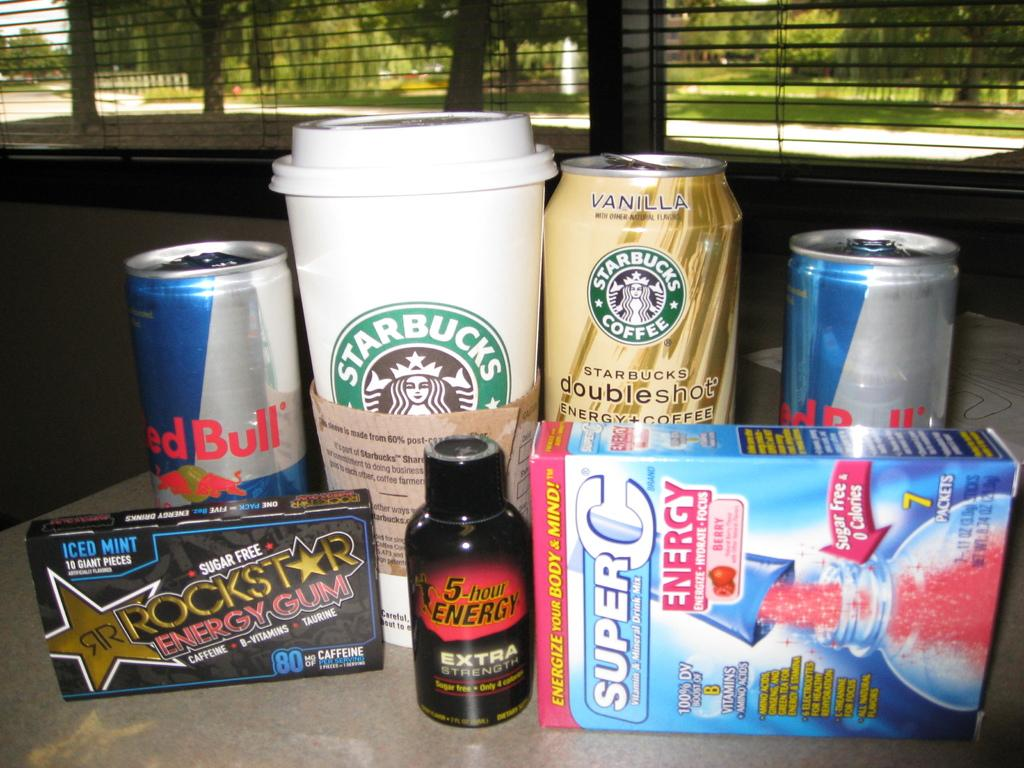<image>
Create a compact narrative representing the image presented. A 5 hour energy shot sits in front of multiple caffeinated beverages. 